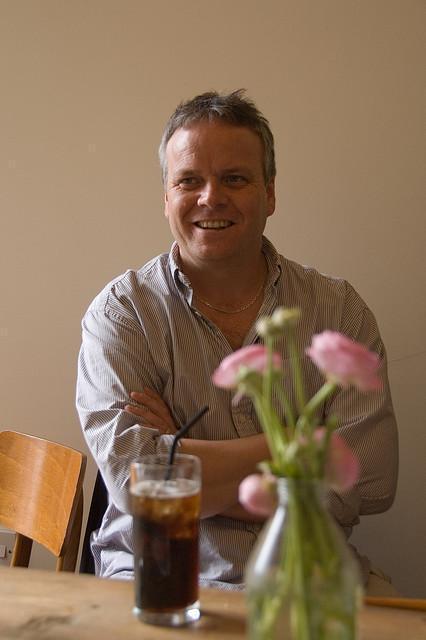How many donuts in the picture?
Give a very brief answer. 0. 